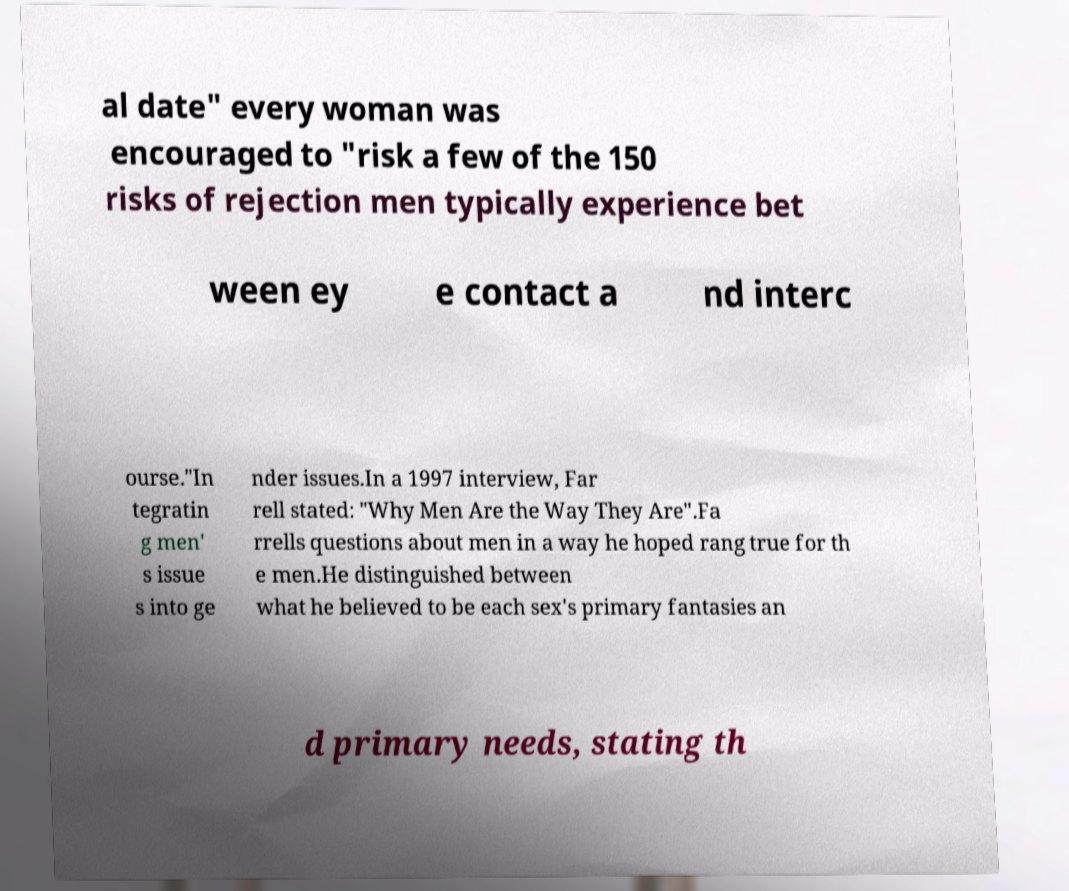For documentation purposes, I need the text within this image transcribed. Could you provide that? al date" every woman was encouraged to "risk a few of the 150 risks of rejection men typically experience bet ween ey e contact a nd interc ourse."In tegratin g men' s issue s into ge nder issues.In a 1997 interview, Far rell stated: "Why Men Are the Way They Are".Fa rrells questions about men in a way he hoped rang true for th e men.He distinguished between what he believed to be each sex's primary fantasies an d primary needs, stating th 